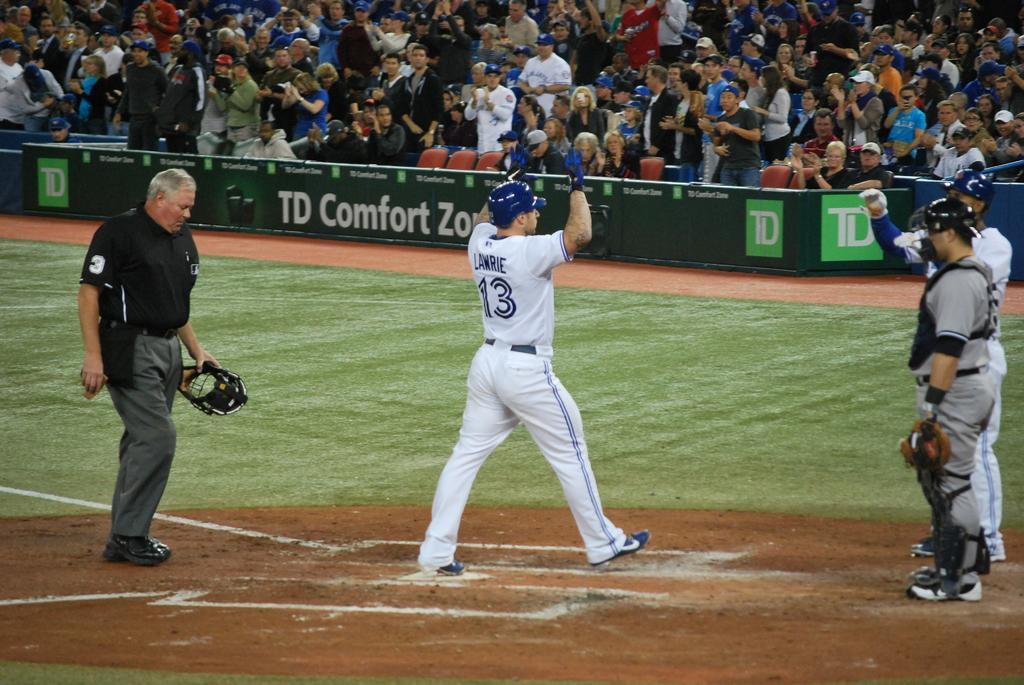<image>
Present a compact description of the photo's key features. Lawrie prepares to give a teammate a high five as he crosses home plate. 